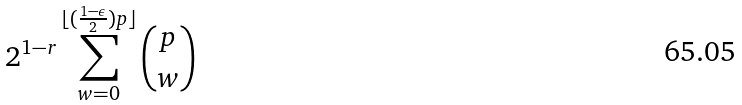Convert formula to latex. <formula><loc_0><loc_0><loc_500><loc_500>2 ^ { 1 - r } \sum _ { w = 0 } ^ { \lfloor ( \frac { 1 - \epsilon } { 2 } ) p \rfloor } { p \choose w }</formula> 